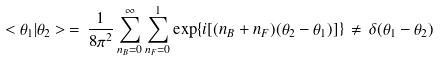Convert formula to latex. <formula><loc_0><loc_0><loc_500><loc_500>< \theta _ { 1 } | \theta _ { 2 } > \, = \, \frac { 1 } { 8 \pi ^ { 2 } } \sum _ { n _ { B } = 0 } ^ { \infty } \sum _ { n _ { F } = 0 } ^ { 1 } \exp \{ i [ ( n _ { B } + n _ { F } ) ( \theta _ { 2 } - \theta _ { 1 } ) ] \} \, \neq \, \delta ( \theta _ { 1 } - \theta _ { 2 } )</formula> 